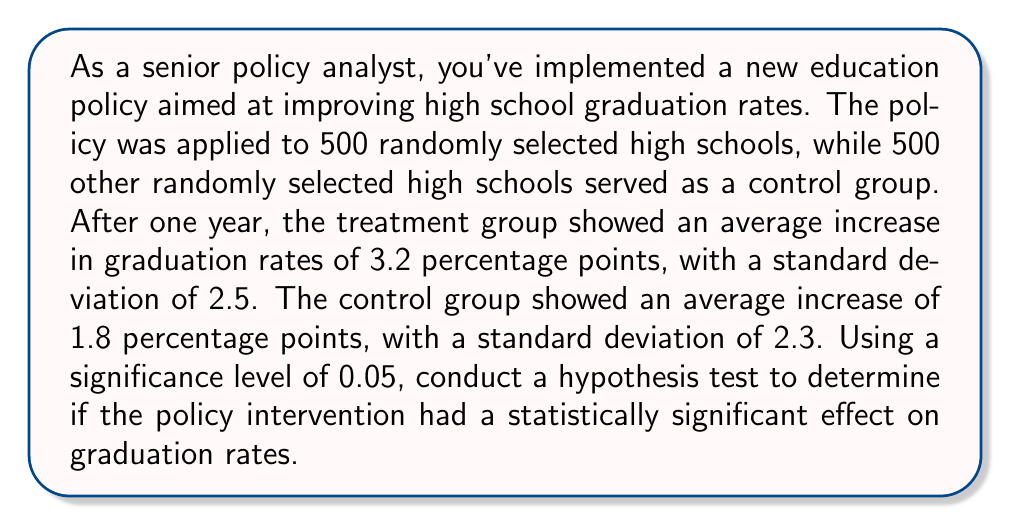Teach me how to tackle this problem. To analyze the statistical significance of the policy intervention, we'll use a two-sample t-test. Here's the step-by-step process:

1. Define the null and alternative hypotheses:
   $H_0: \mu_1 - \mu_2 = 0$ (no difference between treatment and control groups)
   $H_a: \mu_1 - \mu_2 > 0$ (treatment group has a higher increase in graduation rates)

2. Calculate the pooled standard error:
   $$SE = \sqrt{\frac{s_1^2}{n_1} + \frac{s_2^2}{n_2}}$$
   Where $s_1$ and $s_2$ are the standard deviations, and $n_1$ and $n_2$ are the sample sizes.
   
   $$SE = \sqrt{\frac{2.5^2}{500} + \frac{2.3^2}{500}} = \sqrt{0.0125 + 0.0106} = 0.1562$$

3. Calculate the t-statistic:
   $$t = \frac{(\bar{x}_1 - \bar{x}_2) - (\mu_1 - \mu_2)}{SE}$$
   Where $\bar{x}_1$ and $\bar{x}_2$ are the sample means, and $(\mu_1 - \mu_2) = 0$ under the null hypothesis.
   
   $$t = \frac{(3.2 - 1.8) - 0}{0.1562} = \frac{1.4}{0.1562} = 8.96$$

4. Determine the degrees of freedom:
   $df = n_1 + n_2 - 2 = 500 + 500 - 2 = 998$

5. Find the critical t-value for a one-tailed test with $\alpha = 0.05$ and $df = 998$:
   $t_{critical} \approx 1.646$ (using a t-table or calculator)

6. Compare the calculated t-statistic to the critical t-value:
   Since $8.96 > 1.646$, we reject the null hypothesis.

7. Calculate the p-value:
   Using a t-distribution calculator or table, we find that the p-value for $t = 8.96$ with $df = 998$ is $p < 0.0001$.

8. Interpret the results:
   Since $p < 0.0001 < 0.05$, we reject the null hypothesis and conclude that there is strong evidence to support that the policy intervention had a statistically significant positive effect on graduation rates.
Answer: Reject the null hypothesis. The policy intervention had a statistically significant positive effect on graduation rates (t = 8.96, p < 0.0001). 